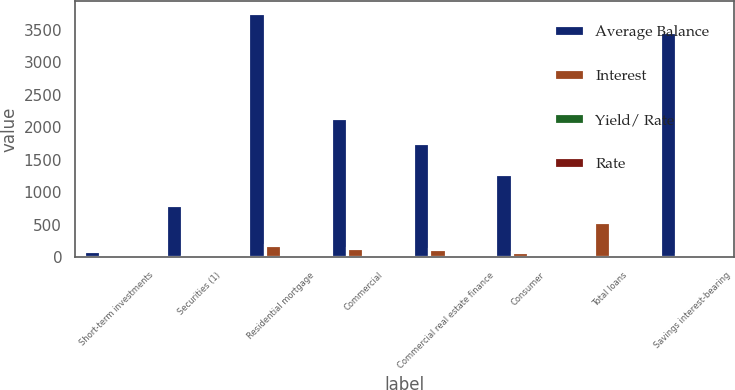<chart> <loc_0><loc_0><loc_500><loc_500><stacked_bar_chart><ecel><fcel>Short-term investments<fcel>Securities (1)<fcel>Residential mortgage<fcel>Commercial<fcel>Commercial real estate finance<fcel>Consumer<fcel>Total loans<fcel>Savings interest-bearing<nl><fcel>Average Balance<fcel>106.6<fcel>803.8<fcel>3758.8<fcel>2135.7<fcel>1765.1<fcel>1288.3<fcel>6.86<fcel>3464.3<nl><fcel>Interest<fcel>5.3<fcel>30<fcel>185.2<fcel>146.5<fcel>126<fcel>88.3<fcel>546<fcel>49.2<nl><fcel>Yield/ Rate<fcel>4.97<fcel>3.74<fcel>4.93<fcel>6.86<fcel>7.14<fcel>6.85<fcel>6.1<fcel>1.42<nl><fcel>Rate<fcel>1.19<fcel>3.23<fcel>4.35<fcel>5.1<fcel>5.96<fcel>4.51<fcel>4.9<fcel>0.81<nl></chart> 